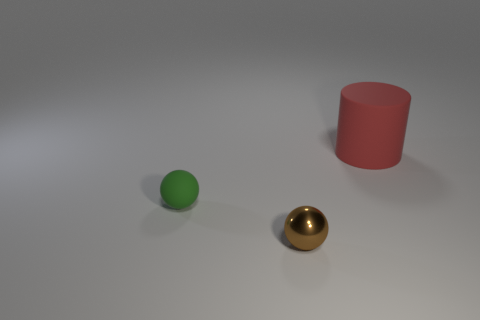Subtract all red spheres. Subtract all purple cubes. How many spheres are left? 2 Add 1 big red cylinders. How many objects exist? 4 Subtract all cylinders. How many objects are left? 2 Add 3 small gray cylinders. How many small gray cylinders exist? 3 Subtract 0 purple spheres. How many objects are left? 3 Subtract all red rubber cylinders. Subtract all tiny green things. How many objects are left? 1 Add 2 small metal spheres. How many small metal spheres are left? 3 